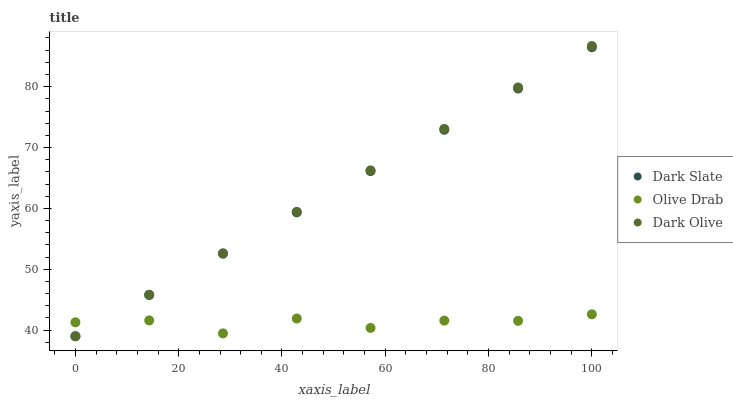Does Olive Drab have the minimum area under the curve?
Answer yes or no. Yes. Does Dark Olive have the maximum area under the curve?
Answer yes or no. Yes. Does Dark Olive have the minimum area under the curve?
Answer yes or no. No. Does Olive Drab have the maximum area under the curve?
Answer yes or no. No. Is Dark Slate the smoothest?
Answer yes or no. Yes. Is Olive Drab the roughest?
Answer yes or no. Yes. Is Dark Olive the smoothest?
Answer yes or no. No. Is Dark Olive the roughest?
Answer yes or no. No. Does Dark Slate have the lowest value?
Answer yes or no. Yes. Does Olive Drab have the lowest value?
Answer yes or no. No. Does Dark Olive have the highest value?
Answer yes or no. Yes. Does Olive Drab have the highest value?
Answer yes or no. No. Does Dark Olive intersect Olive Drab?
Answer yes or no. Yes. Is Dark Olive less than Olive Drab?
Answer yes or no. No. Is Dark Olive greater than Olive Drab?
Answer yes or no. No. 